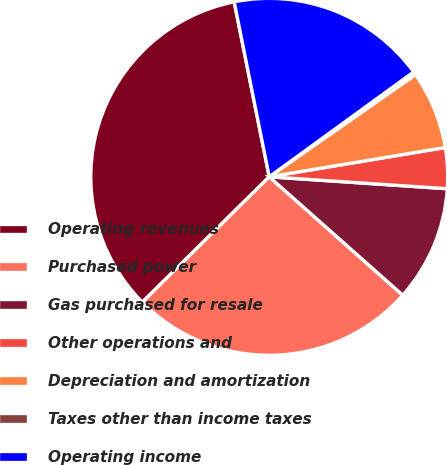Convert chart to OTSL. <chart><loc_0><loc_0><loc_500><loc_500><pie_chart><fcel>Operating revenues<fcel>Purchased power<fcel>Gas purchased for resale<fcel>Other operations and<fcel>Depreciation and amortization<fcel>Taxes other than income taxes<fcel>Operating income<nl><fcel>34.25%<fcel>26.05%<fcel>10.48%<fcel>3.69%<fcel>7.08%<fcel>0.29%<fcel>18.15%<nl></chart> 